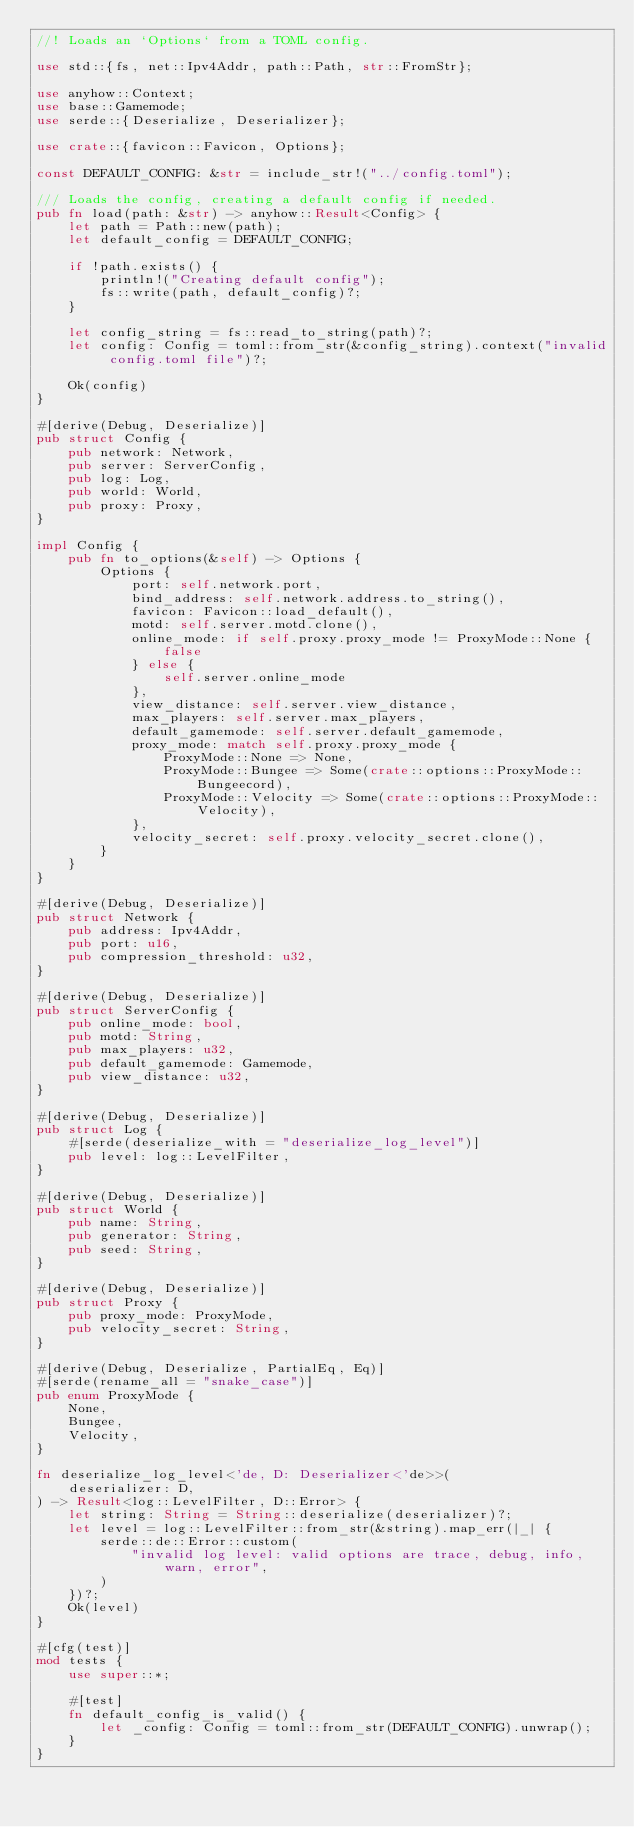Convert code to text. <code><loc_0><loc_0><loc_500><loc_500><_Rust_>//! Loads an `Options` from a TOML config.

use std::{fs, net::Ipv4Addr, path::Path, str::FromStr};

use anyhow::Context;
use base::Gamemode;
use serde::{Deserialize, Deserializer};

use crate::{favicon::Favicon, Options};

const DEFAULT_CONFIG: &str = include_str!("../config.toml");

/// Loads the config, creating a default config if needed.
pub fn load(path: &str) -> anyhow::Result<Config> {
    let path = Path::new(path);
    let default_config = DEFAULT_CONFIG;

    if !path.exists() {
        println!("Creating default config");
        fs::write(path, default_config)?;
    }

    let config_string = fs::read_to_string(path)?;
    let config: Config = toml::from_str(&config_string).context("invalid config.toml file")?;

    Ok(config)
}

#[derive(Debug, Deserialize)]
pub struct Config {
    pub network: Network,
    pub server: ServerConfig,
    pub log: Log,
    pub world: World,
    pub proxy: Proxy,
}

impl Config {
    pub fn to_options(&self) -> Options {
        Options {
            port: self.network.port,
            bind_address: self.network.address.to_string(),
            favicon: Favicon::load_default(),
            motd: self.server.motd.clone(),
            online_mode: if self.proxy.proxy_mode != ProxyMode::None {
                false
            } else {
                self.server.online_mode
            },
            view_distance: self.server.view_distance,
            max_players: self.server.max_players,
            default_gamemode: self.server.default_gamemode,
            proxy_mode: match self.proxy.proxy_mode {
                ProxyMode::None => None,
                ProxyMode::Bungee => Some(crate::options::ProxyMode::Bungeecord),
                ProxyMode::Velocity => Some(crate::options::ProxyMode::Velocity),
            },
            velocity_secret: self.proxy.velocity_secret.clone(),
        }
    }
}

#[derive(Debug, Deserialize)]
pub struct Network {
    pub address: Ipv4Addr,
    pub port: u16,
    pub compression_threshold: u32,
}

#[derive(Debug, Deserialize)]
pub struct ServerConfig {
    pub online_mode: bool,
    pub motd: String,
    pub max_players: u32,
    pub default_gamemode: Gamemode,
    pub view_distance: u32,
}

#[derive(Debug, Deserialize)]
pub struct Log {
    #[serde(deserialize_with = "deserialize_log_level")]
    pub level: log::LevelFilter,
}

#[derive(Debug, Deserialize)]
pub struct World {
    pub name: String,
    pub generator: String,
    pub seed: String,
}

#[derive(Debug, Deserialize)]
pub struct Proxy {
    pub proxy_mode: ProxyMode,
    pub velocity_secret: String,
}

#[derive(Debug, Deserialize, PartialEq, Eq)]
#[serde(rename_all = "snake_case")]
pub enum ProxyMode {
    None,
    Bungee,
    Velocity,
}

fn deserialize_log_level<'de, D: Deserializer<'de>>(
    deserializer: D,
) -> Result<log::LevelFilter, D::Error> {
    let string: String = String::deserialize(deserializer)?;
    let level = log::LevelFilter::from_str(&string).map_err(|_| {
        serde::de::Error::custom(
            "invalid log level: valid options are trace, debug, info, warn, error",
        )
    })?;
    Ok(level)
}

#[cfg(test)]
mod tests {
    use super::*;

    #[test]
    fn default_config_is_valid() {
        let _config: Config = toml::from_str(DEFAULT_CONFIG).unwrap();
    }
}
</code> 